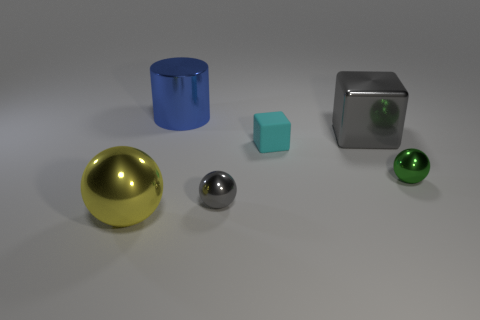Add 4 tiny metal spheres. How many objects exist? 10 Subtract all cylinders. How many objects are left? 5 Subtract all yellow metal balls. Subtract all big yellow balls. How many objects are left? 4 Add 3 yellow metallic objects. How many yellow metallic objects are left? 4 Add 1 tiny yellow cylinders. How many tiny yellow cylinders exist? 1 Subtract 0 green cylinders. How many objects are left? 6 